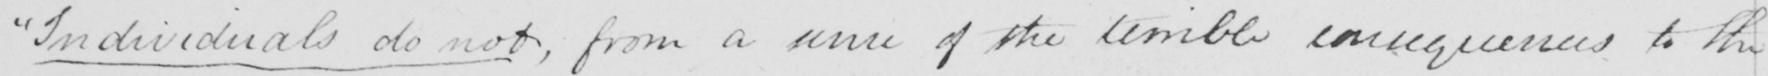What text is written in this handwritten line? " Individuals do not , from a sense of the terrible consequences to the 